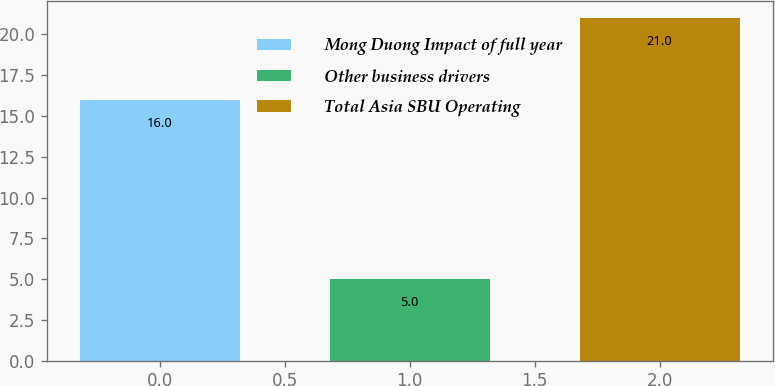Convert chart to OTSL. <chart><loc_0><loc_0><loc_500><loc_500><bar_chart><fcel>Mong Duong Impact of full year<fcel>Other business drivers<fcel>Total Asia SBU Operating<nl><fcel>16<fcel>5<fcel>21<nl></chart> 